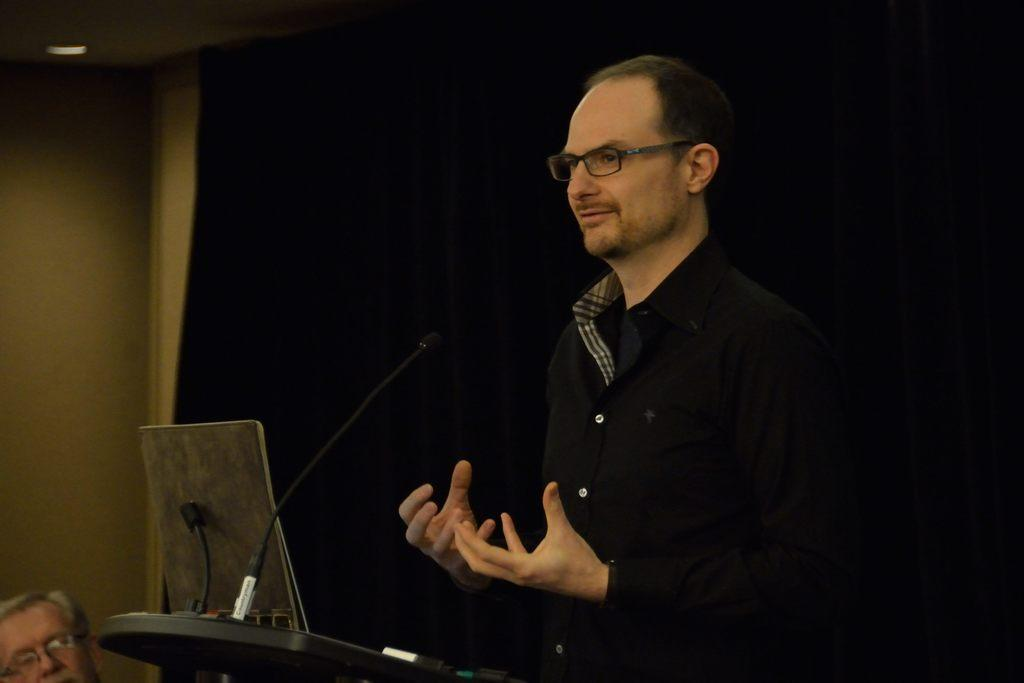What is the person in the image doing? The person in the image is talking in front of a microphone. What object is on the table in the image? There is a laptop on the table. Can you describe what is visible on the laptop screen? There is another person visible on the left side of the laptop screen. What type of salt is being sprinkled on the microphone in the image? There is no salt present in the image, and the microphone is not being sprinkled with anything. What color is the curtain behind the person talking in the image? There is no curtain visible in the image; the background is not mentioned in the provided facts. 